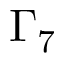Convert formula to latex. <formula><loc_0><loc_0><loc_500><loc_500>\Gamma _ { 7 }</formula> 